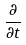Convert formula to latex. <formula><loc_0><loc_0><loc_500><loc_500>\frac { \partial } { \partial t }</formula> 